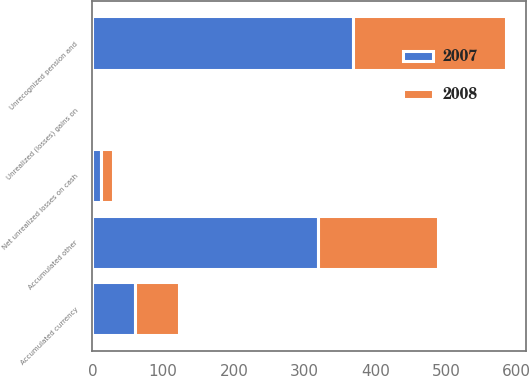Convert chart to OTSL. <chart><loc_0><loc_0><loc_500><loc_500><stacked_bar_chart><ecel><fcel>Unrecognized pension and<fcel>Accumulated currency<fcel>Net unrealized losses on cash<fcel>Unrealized (losses) gains on<fcel>Accumulated other<nl><fcel>2007<fcel>368<fcel>60.9<fcel>11.8<fcel>0.1<fcel>319<nl><fcel>2008<fcel>216.7<fcel>61.2<fcel>16.7<fcel>2.5<fcel>169.7<nl></chart> 